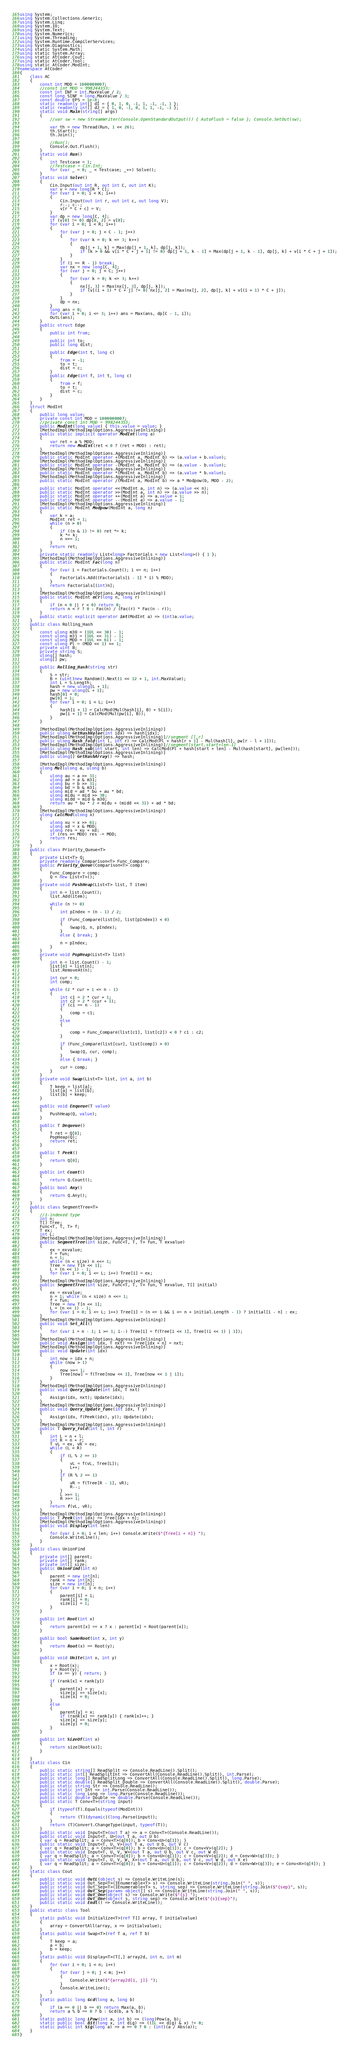Convert code to text. <code><loc_0><loc_0><loc_500><loc_500><_C#_>using System;
using System.Collections.Generic;
using System.Linq;
using System.IO;
using System.Text;
using System.Numerics;
using System.Threading;
using System.Runtime.CompilerServices;
using System.Diagnostics;
using static System.Math;
using static System.Array;
using static AtCoder.Cout;
using static AtCoder.Tool;
using static AtCoder.ModInt;
namespace AtCoder
{
    class AC
    {
        const int MOD = 1000000007;
        //const int MOD = 998244353;
        const int INF = int.MaxValue / 2;
        const long SINF = long.MaxValue / 3;
        const double EPS = 1e-8;
        static readonly int[] dI = { 0, 1, 0, -1, 1, -1, -1, 1 };
        static readonly int[] dJ = { 1, 0, -1, 0, 1, 1, -1, -1 };
        static void Main(string[] args)
        {
            //var sw = new StreamWriter(Console.OpenStandardOutput()) { AutoFlush = false }; Console.SetOut(sw);

            var th = new Thread(Run, 1 << 26);
            th.Start();
            th.Join();

            //Run();
            Console.Out.Flush();
        }
        static void Run()
        {
            int Testcase = 1;
            //Testcase = Cin.Int;
            for (var _ = 0; _ < Testcase; _++) Solve();
        }
        static void Solve()
        {
            Cin.Input(out int R, out int C, out int K);
            var v = new long[R * C];
            for (var i = 0; i < K; i++)
            {
                Cin.Input(out int r, out int c, out long V);
                r--; c--;
                v[r * C + c] = V;
            }
            var dp = new long[C, 4];
            if (v[0] != 0) dp[0, 2] = v[0];
            for (var i = 0; i < R; i++)
            {
                for (var j = 0; j < C - 1; j++)
                {
                    for (var k = 0; k <= 3; k++)
                    {
                        dp[j + 1, k] = Max(dp[j + 1, k], dp[j, k]);
                        if (k > 0 && v[i * C + j + 1] != 0) dp[j + 1, k - 1] = Max(dp[j + 1, k - 1], dp[j, k] + v[i * C + j + 1]);
                    }
                }
                if (i == R - 1) break;
                var nx = new long[C, 4];
                for (var j = 0; j < C; j++)
                {
                    for (var k = 0; k <= 3; k++)
                    {
                        nx[j, 3] = Max(nx[j, 3], dp[j, k]);
                        if (v[(i + 1) * C + j] != 0) nx[j, 2] = Max(nx[j, 2], dp[j, k] + v[(i + 1) * C + j]);
                    }
                }
                dp = nx;
            }
            long ans = 0;
            for (var i = 0; i <= 3; i++) ans = Max(ans, dp[C - 1, i]);
            OutL(ans);
        }
        public struct Edge
        {
            public int from;

            public int to;
            public long dist;

            public Edge(int t, long c)
            {
                from = -1;
                to = t;
                dist = c;
            }
            public Edge(int f, int t, long c)
            {
                from = f;
                to = t;
                dist = c;
            }
        }
    }
    struct ModInt
    {
        public long value;
        private const int MOD = 1000000007;
        //private const int MOD = 998244353;
        public ModInt(long value) { this.value = value; }
        [MethodImpl(MethodImplOptions.AggressiveInlining)]
        public static implicit operator ModInt(long a)
        {
            var ret = a % MOD;
            return new ModInt(ret < 0 ? (ret + MOD) : ret);
        }
        [MethodImpl(MethodImplOptions.AggressiveInlining)]
        public static ModInt operator +(ModInt a, ModInt b) => (a.value + b.value);
        [MethodImpl(MethodImplOptions.AggressiveInlining)]
        public static ModInt operator -(ModInt a, ModInt b) => (a.value - b.value);
        [MethodImpl(MethodImplOptions.AggressiveInlining)]
        public static ModInt operator *(ModInt a, ModInt b) => (a.value * b.value);
        [MethodImpl(MethodImplOptions.AggressiveInlining)]
        public static ModInt operator /(ModInt a, ModInt b) => a * Modpow(b, MOD - 2);

        public static ModInt operator <<(ModInt a, int n) => (a.value << n);
        public static ModInt operator >>(ModInt a, int n) => (a.value >> n);
        public static ModInt operator ++(ModInt a) => a.value + 1;
        public static ModInt operator --(ModInt a) => a.value - 1;
        [MethodImpl(MethodImplOptions.AggressiveInlining)]
        public static ModInt Modpow(ModInt a, long n)
        {
            var k = a;
            ModInt ret = 1;
            while (n > 0)
            {
                if ((n & 1) != 0) ret *= k;
                k *= k;
                n >>= 1;
            }
            return ret;
        }
        private static readonly List<long> Factorials = new List<long>() { 1 };
        [MethodImpl(MethodImplOptions.AggressiveInlining)]
        public static ModInt Fac(long n)
        {
            for (var i = Factorials.Count(); i <= n; i++)
            {
                Factorials.Add((Factorials[i - 1] * i) % MOD);
            }
            return Factorials[(int)n];
        }
        [MethodImpl(MethodImplOptions.AggressiveInlining)]
        public static ModInt nCr(long n, long r)
        {
            if (n < 0 || r < 0) return 0;
            return n < r ? 0 : Fac(n) / (Fac(r) * Fac(n - r));
        }
        public static explicit operator int(ModInt a) => (int)a.value;
    }
    public class Rolling_Hash
    {
        const ulong m30 = (1UL << 30) - 1;
        const ulong m31 = (1UL << 31) - 1;
        const ulong MOD = (1UL << 61) - 1;
        const ulong Pl = (MOD << 1) << 1;
        private uint B;
        private string S;
        ulong[] hash;
        ulong[] pw;

        public Rolling_Hash(string str)
        {
            S = str;
            B = (uint)new Random().Next(1 << 12 + 1, int.MaxValue);
            int L = S.Length;
            hash = new ulong[L + 1];
            pw = new ulong[L + 1];
            hash[0] = 0;
            pw[0] = 1;
            for (var i = 0; i < L; i++)
            {
                hash[i + 1] = CalcMod(Mul(hash[i], B) + S[i]);
                pw[i + 1] = CalcMod(Mul(pw[i], B));
            }
        }

        [MethodImpl(MethodImplOptions.AggressiveInlining)]
        public ulong GetHashValue(int idx) => hash[idx];
        [MethodImpl(MethodImplOptions.AggressiveInlining)]//segment [l,r]
        public ulong Hash_fold(int l, int r) => CalcMod(Pl + hash[r + 1] - Mul(hash[l], pw[r - l + 1]));
        [MethodImpl(MethodImplOptions.AggressiveInlining)]//segment[start,start+len-1]
        public ulong Hash_sub(int start, int len) => CalcMod(Pl + hash[start + len] - Mul(hash[start], pw[len]));
        [MethodImpl(MethodImplOptions.AggressiveInlining)]
        public ulong[] GetHashArray() => hash;

        [MethodImpl(MethodImplOptions.AggressiveInlining)]
        ulong Mul(ulong a, ulong b)
        {
            ulong au = a >> 31;
            ulong ad = a & m31;
            ulong bu = b >> 31;
            ulong bd = b & m31;
            ulong mid = ad * bu + au * bd;
            ulong midu = mid >> 30;
            ulong midd = mid & m30;
            return au * bu * 2 + midu + (midd << 31) + ad * bd;
        }
        [MethodImpl(MethodImplOptions.AggressiveInlining)]
        ulong CalcMod(ulong x)
        {
            ulong xu = x >> 61;
            ulong xd = x & MOD;
            ulong res = xu + xd;
            if (res >= MOD) res -= MOD;
            return res;
        }
    }
    public class Priority_Queue<T>
    {
        private List<T> Q;
        private readonly Comparison<T> Func_Compare;
        public Priority_Queue(Comparison<T> comp)
        {
            Func_Compare = comp;
            Q = new List<T>();
        }
        private void PushHeap(List<T> list, T item)
        {
            int n = list.Count();
            list.Add(item);

            while (n != 0)
            {
                int pIndex = (n - 1) / 2;

                if (Func_Compare(list[n], list[pIndex]) < 0)
                {
                    Swap(Q, n, pIndex);
                }
                else { break; }

                n = pIndex;
            }
        }
        private void PopHeap(List<T> list)
        {
            int n = list.Count() - 1;
            list[0] = list[n];
            list.RemoveAt(n);

            int cur = 0;
            int comp;

            while (2 * cur + 1 <= n - 1)
            {
                int c1 = 2 * cur + 1;
                int c2 = 2 * (cur + 1);
                if (c1 == n - 1)
                {
                    comp = c1;
                }
                else
                {

                    comp = Func_Compare(list[c1], list[c2]) < 0 ? c1 : c2;
                }

                if (Func_Compare(list[cur], list[comp]) > 0)
                {
                    Swap(Q, cur, comp);
                }
                else { break; }

                cur = comp;
            }
        }
        private void Swap(List<T> list, int a, int b)
        {
            T keep = list[a];
            list[a] = list[b];
            list[b] = keep;
        }

        public void Enqueue(T value)
        {
            PushHeap(Q, value);
        }

        public T Dequeue()
        {
            T ret = Q[0];
            PopHeap(Q);
            return ret;
        }

        public T Peek()
        {
            return Q[0];
        }

        public int Count()
        {
            return Q.Count();
        }
        public bool Any()
        {
            return Q.Any();
        }
    }
    public class SegmentTree<T>
    {
        //1-indexed type
        int n;
        T[] Tree;
        Func<T, T, T> f;
        T ex;
        int L;
        [MethodImpl(MethodImplOptions.AggressiveInlining)]
        public SegmentTree(int size, Func<T, T, T> fun, T exvalue)
        {
            ex = exvalue;
            f = fun;
            n = 1;
            while (n < size) n <<= 1;
            Tree = new T[n << 1];
            L = (n << 1) - 1;
            for (var i = 0; i <= L; i++) Tree[i] = ex;
        }
        [MethodImpl(MethodImplOptions.AggressiveInlining)]
        public SegmentTree(int size, Func<T, T, T> fun, T exvalue, T[] initial)
        {
            ex = exvalue;
            n = 1; while (n < size) n <<= 1;
            f = fun;
            Tree = new T[n << 1];
            L = (n << 1) - 1;
            for (var i = 0; i <= L; i++) Tree[i] = (n <= i && i <= n + initial.Length - 1) ? initial[i - n] : ex;
        }
        [MethodImpl(MethodImplOptions.AggressiveInlining)]
        public void Set_All()
        {
            for (var i = n - 1; i >= 1; i--) Tree[i] = f(Tree[i << 1], Tree[(i << 1) | 1]);
        }
        [MethodImpl(MethodImplOptions.AggressiveInlining)]
        public void Assign(int idx, T nxt) => Tree[idx + n] = nxt;
        [MethodImpl(MethodImplOptions.AggressiveInlining)]
        public void Update(int idx)
        {
            int now = idx + n;
            while (now > 1)
            {
                now >>= 1;
                Tree[now] = f(Tree[now << 1], Tree[now << 1 | 1]);
            }
        }
        [MethodImpl(MethodImplOptions.AggressiveInlining)]
        public void Query_Update(int idx, T nxt)
        {
            Assign(idx, nxt); Update(idx);
        }
        [MethodImpl(MethodImplOptions.AggressiveInlining)]
        public void Query_Update_func(int idx, T y)
        {
            Assign(idx, f(Peek(idx), y)); Update(idx);
        }
        [MethodImpl(MethodImplOptions.AggressiveInlining)]
        public T Query_Fold(int l, int r)
        {
            int L = n + l;
            int R = n + r;
            T vL = ex, vR = ex;
            while (L < R)
            {
                if (L % 2 == 1)
                {
                    vL = f(vL, Tree[L]);
                    L++;
                }
                if (R % 2 == 1)
                {
                    vR = f(Tree[R - 1], vR);
                    R--;
                }
                L >>= 1;
                R >>= 1;
            }
            return f(vL, vR);
        }
        [MethodImpl(MethodImplOptions.AggressiveInlining)]
        public T Peek(int idx) => Tree[idx + n];
        [MethodImpl(MethodImplOptions.AggressiveInlining)]
        public void Display(int len)
        {
            for (var i = 0; i < len; i++) Console.Write($"{Tree[i + n]} ");
            Console.WriteLine();
        }
    }
    public class UnionFind
    {
        private int[] parent;
        private int[] rank;
        private int[] size;
        public UnionFind(int n)
        {
            parent = new int[n];
            rank = new int[n];
            size = new int[n];
            for (var i = 0; i < n; i++)
            {
                parent[i] = i;
                rank[i] = 0;
                size[i] = 1;
            }
        }

        public int Root(int x)
        {
            return parent[x] == x ? x : parent[x] = Root(parent[x]);
        }

        public bool SameRoot(int x, int y)
        {
            return Root(x) == Root(y);
        }

        public void Unite(int x, int y)
        {
            x = Root(x);
            y = Root(y);
            if (x == y) { return; }

            if (rank[x] < rank[y])
            {
                parent[x] = y;
                size[y] += size[x];
                size[x] = 0;
            }
            else
            {
                parent[y] = x;
                if (rank[x] == rank[y]) { rank[x]++; }
                size[x] += size[y];
                size[y] = 0;
            }
        }

        public int SizeOf(int x)
        {
            return size[Root(x)];
        }

    }
    static class Cin
    {
        public static string[] ReadSplit => Console.ReadLine().Split();
        public static int[] ReadSplitInt => ConvertAll(Console.ReadLine().Split(), int.Parse);
        public static long[] ReadSplitLong => ConvertAll(Console.ReadLine().Split(), long.Parse);
        public static double[] ReadSplit_Double => ConvertAll(Console.ReadLine().Split(), double.Parse);
        public static string Str => Console.ReadLine();
        public static int Int => int.Parse(Console.ReadLine());
        public static long Long => long.Parse(Console.ReadLine());
        public static double Double => double.Parse(Console.ReadLine());
        public static T Conv<T>(string input)
        {
            if (typeof(T).Equals(typeof(ModInt)))
            {
                return (T)(dynamic)(long.Parse(input));
            }
            return (T)Convert.ChangeType(input, typeof(T));
        }
        public static void Input<T>(out T a) => a = Conv<T>(Console.ReadLine());
        public static void Input<T, U>(out T a, out U b)
        { var q = ReadSplit; a = Conv<T>(q[0]); b = Conv<U>(q[1]); }
        public static void Input<T, U, V>(out T a, out U b, out V c)
        { var q = ReadSplit; a = Conv<T>(q[0]); b = Conv<U>(q[1]); c = Conv<V>(q[2]); }
        public static void Input<T, U, V, W>(out T a, out U b, out V c, out W d)
        { var q = ReadSplit; a = Conv<T>(q[0]); b = Conv<U>(q[1]); c = Conv<V>(q[2]); d = Conv<W>(q[3]); }
        public static void Input<T, U, V, W, X>(out T a, out U b, out V c, out W d, out X e)
        { var q = ReadSplit; a = Conv<T>(q[0]); b = Conv<U>(q[1]); c = Conv<V>(q[2]); d = Conv<W>(q[3]); e = Conv<X>(q[4]); }
    }
    static class Cout
    {
        public static void OutL(object s) => Console.WriteLine(s);
        public static void Out_Sep<T>(IEnumerable<T> s) => Console.WriteLine(string.Join(" ", s));
        public static void Out_Sep<T>(IEnumerable<T> s, string sep) => Console.WriteLine(string.Join($"{sep}", s));
        public static void Out_Sep(params object[] s) => Console.WriteLine(string.Join(" ", s));
        public static void Out_One(object s) => Console.Write($"{s} ");
        public static void Out_One(object s, string sep) => Console.Write($"{s}{sep}");
        public static void Endl() => Console.WriteLine();
    }
    public static class Tool
    {
        static public void Initialize<T>(ref T[] array, T initialvalue)
        {
            array = ConvertAll(array, x => initialvalue);
        }
        static public void Swap<T>(ref T a, ref T b)
        {
            T keep = a;
            a = b;
            b = keep;
        }
        static public void Display<T>(T[,] array2d, int n, int m)
        {
            for (var i = 0; i < n; i++)
            {
                for (var j = 0; j < m; j++)
                {
                    Console.Write($"{array2d[i, j]} ");
                }
                Console.WriteLine();
            }
        }
        static public long Gcd(long a, long b)
        {
            if (a == 0 || b == 0) return Max(a, b);
            return a % b == 0 ? b : Gcd(b, a % b);
        }
        static public long LPow(int a, int b) => (long)Pow(a, b);
        static public bool Bit(long x, int dig) => ((1L << dig) & x) != 0;
        static public int Sig(long a) => a == 0 ? 0 : (int)(a / Abs(a));
    }
}
</code> 